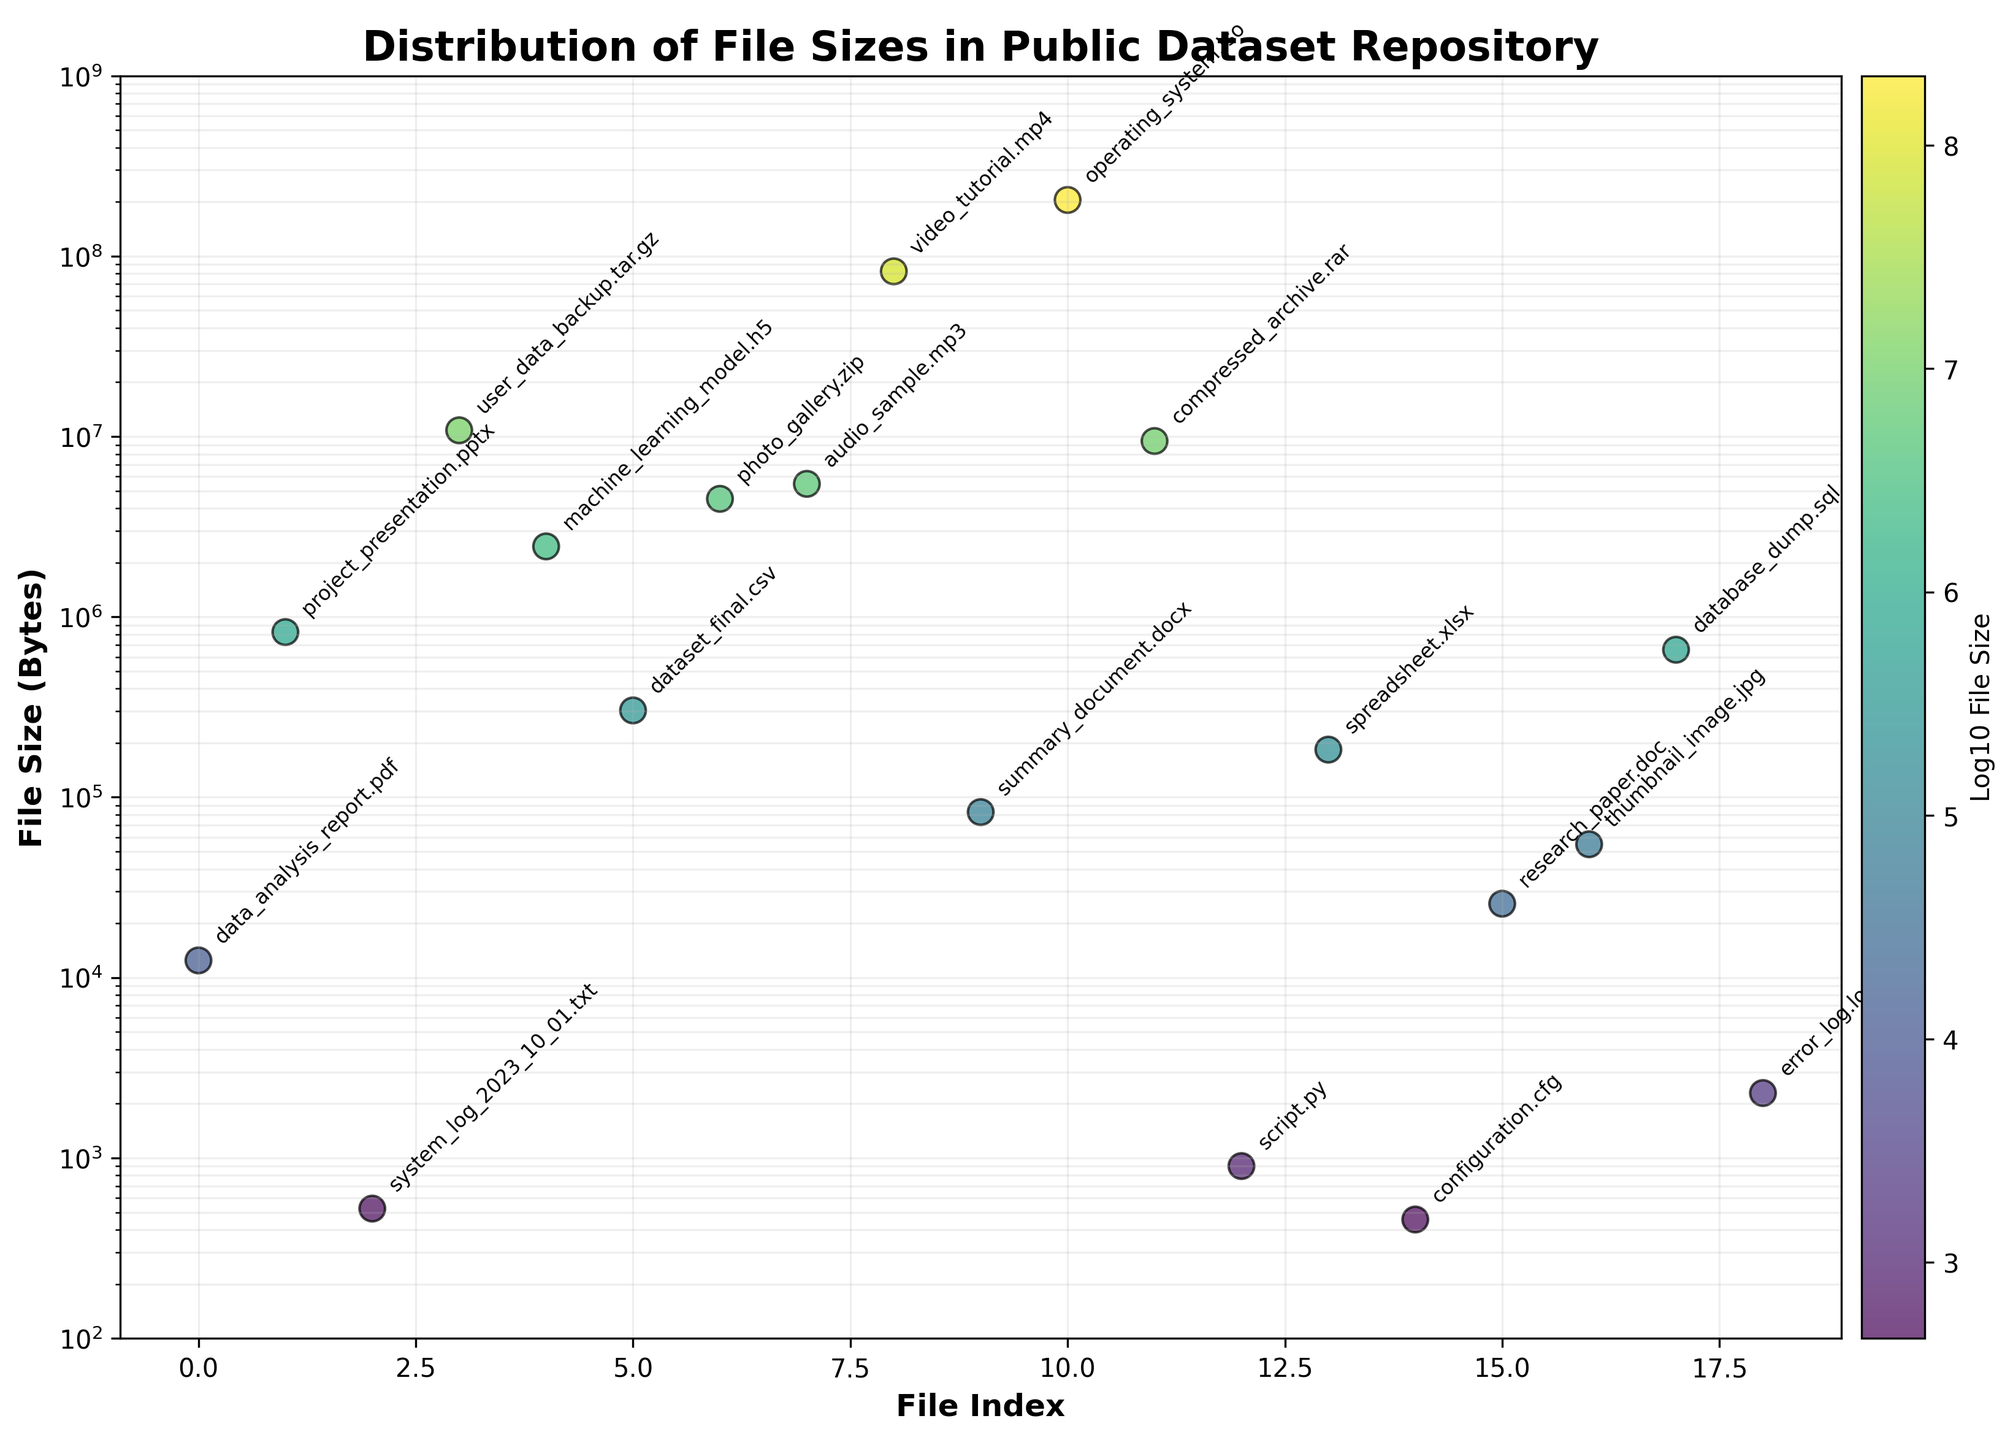what is the title of the figure? The title is displayed at the top of the figure in bold. Reading it directly gives us the answer.
Answer: Distribution of File Sizes in Public Dataset Repository How many data points are there in the plot? Each data point represents a file size. By counting all the scatter points visually, we can determine the total number of data points.
Answer: 18 What is the color scheme used in the scatter plot? The scatter plot uses a color scheme to represent the log-scaled file sizes. This can be determined by observing the color distribution in the scatter points and the color bar.
Answer: viridis Which file has the smallest size, and what is its size? Observing the y-axis, which is in log scale, helps identify the lowest point on the plot. The file annotated at the lowest point will be the smallest in size.
Answer: configuration.cfg, 456 bytes What file has the largest size, and what is its size? Similarly, identifying the highest point on the plot, and reading the annotation will reveal the file with the largest size.
Answer: operating_system.iso, 204,857,600 bytes How many files have a size greater than 10,000,000 bytes? Visually inspect the plot to count the number of scatter points that are above the 10^7 mark on the y-axis, and read the appropriate annotations.
Answer: 5 Which file sizes fall within the range of 1,000,000 to 10,000,000 bytes? Identify the scatter points that fall between 10^6 and 10^7 on the y-axis, then read the annotations of the corresponding points.
Answer: dataset_final.csv, machine_learning_model.h5, compressed_archive.rar What is the average size of the files in the dataset? Sum the sizes of all 18 files and divide by the number of files to get the average. (12456 + 823500 + 524 + 10823573 + 2458901 + 302918 + 4512763 + 5463723 + 82347631 + 82732 + 204857600 + 9438912 + 902 + 183673 + 456 + 25689 + 54871 + 657439 = 335679753, then divide by 18)
Answer: 18,648,875.17 bytes How does the file size of the 'video_tutorial.mp4' compare to that of 'audio_sample.mp3'? Locate both points on the y-axis and compare their positions. Read their annotations for exact values. 'video_tutorial.mp4' is substantially higher than 'audio_sample.mp3'.
Answer: video_tutorial.mp4 > audio_sample.mp3 